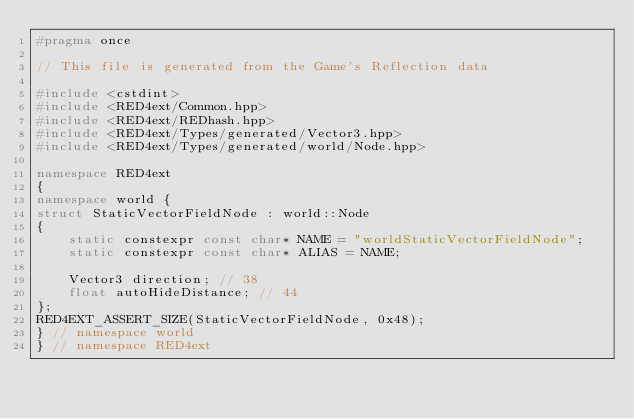Convert code to text. <code><loc_0><loc_0><loc_500><loc_500><_C++_>#pragma once

// This file is generated from the Game's Reflection data

#include <cstdint>
#include <RED4ext/Common.hpp>
#include <RED4ext/REDhash.hpp>
#include <RED4ext/Types/generated/Vector3.hpp>
#include <RED4ext/Types/generated/world/Node.hpp>

namespace RED4ext
{
namespace world { 
struct StaticVectorFieldNode : world::Node
{
    static constexpr const char* NAME = "worldStaticVectorFieldNode";
    static constexpr const char* ALIAS = NAME;

    Vector3 direction; // 38
    float autoHideDistance; // 44
};
RED4EXT_ASSERT_SIZE(StaticVectorFieldNode, 0x48);
} // namespace world
} // namespace RED4ext
</code> 